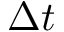<formula> <loc_0><loc_0><loc_500><loc_500>\Delta t</formula> 